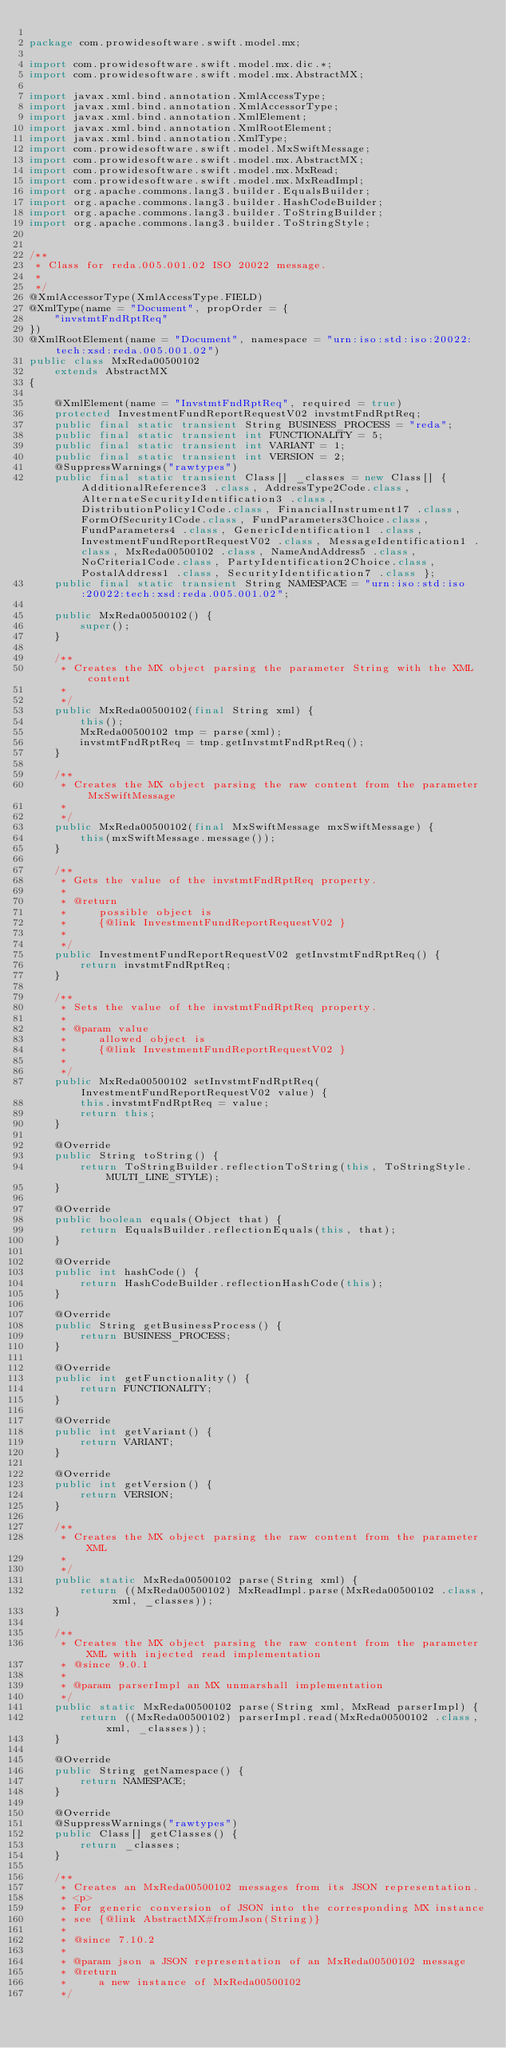<code> <loc_0><loc_0><loc_500><loc_500><_Java_>
package com.prowidesoftware.swift.model.mx;

import com.prowidesoftware.swift.model.mx.dic.*;
import com.prowidesoftware.swift.model.mx.AbstractMX;

import javax.xml.bind.annotation.XmlAccessType;
import javax.xml.bind.annotation.XmlAccessorType;
import javax.xml.bind.annotation.XmlElement;
import javax.xml.bind.annotation.XmlRootElement;
import javax.xml.bind.annotation.XmlType;
import com.prowidesoftware.swift.model.MxSwiftMessage;
import com.prowidesoftware.swift.model.mx.AbstractMX;
import com.prowidesoftware.swift.model.mx.MxRead;
import com.prowidesoftware.swift.model.mx.MxReadImpl;
import org.apache.commons.lang3.builder.EqualsBuilder;
import org.apache.commons.lang3.builder.HashCodeBuilder;
import org.apache.commons.lang3.builder.ToStringBuilder;
import org.apache.commons.lang3.builder.ToStringStyle;


/**
 * Class for reda.005.001.02 ISO 20022 message.
 * 
 */
@XmlAccessorType(XmlAccessType.FIELD)
@XmlType(name = "Document", propOrder = {
    "invstmtFndRptReq"
})
@XmlRootElement(name = "Document", namespace = "urn:iso:std:iso:20022:tech:xsd:reda.005.001.02")
public class MxReda00500102
    extends AbstractMX
{

    @XmlElement(name = "InvstmtFndRptReq", required = true)
    protected InvestmentFundReportRequestV02 invstmtFndRptReq;
    public final static transient String BUSINESS_PROCESS = "reda";
    public final static transient int FUNCTIONALITY = 5;
    public final static transient int VARIANT = 1;
    public final static transient int VERSION = 2;
    @SuppressWarnings("rawtypes")
    public final static transient Class[] _classes = new Class[] {AdditionalReference3 .class, AddressType2Code.class, AlternateSecurityIdentification3 .class, DistributionPolicy1Code.class, FinancialInstrument17 .class, FormOfSecurity1Code.class, FundParameters3Choice.class, FundParameters4 .class, GenericIdentification1 .class, InvestmentFundReportRequestV02 .class, MessageIdentification1 .class, MxReda00500102 .class, NameAndAddress5 .class, NoCriteria1Code.class, PartyIdentification2Choice.class, PostalAddress1 .class, SecurityIdentification7 .class };
    public final static transient String NAMESPACE = "urn:iso:std:iso:20022:tech:xsd:reda.005.001.02";

    public MxReda00500102() {
        super();
    }

    /**
     * Creates the MX object parsing the parameter String with the XML content
     * 
     */
    public MxReda00500102(final String xml) {
        this();
        MxReda00500102 tmp = parse(xml);
        invstmtFndRptReq = tmp.getInvstmtFndRptReq();
    }

    /**
     * Creates the MX object parsing the raw content from the parameter MxSwiftMessage
     * 
     */
    public MxReda00500102(final MxSwiftMessage mxSwiftMessage) {
        this(mxSwiftMessage.message());
    }

    /**
     * Gets the value of the invstmtFndRptReq property.
     * 
     * @return
     *     possible object is
     *     {@link InvestmentFundReportRequestV02 }
     *     
     */
    public InvestmentFundReportRequestV02 getInvstmtFndRptReq() {
        return invstmtFndRptReq;
    }

    /**
     * Sets the value of the invstmtFndRptReq property.
     * 
     * @param value
     *     allowed object is
     *     {@link InvestmentFundReportRequestV02 }
     *     
     */
    public MxReda00500102 setInvstmtFndRptReq(InvestmentFundReportRequestV02 value) {
        this.invstmtFndRptReq = value;
        return this;
    }

    @Override
    public String toString() {
        return ToStringBuilder.reflectionToString(this, ToStringStyle.MULTI_LINE_STYLE);
    }

    @Override
    public boolean equals(Object that) {
        return EqualsBuilder.reflectionEquals(this, that);
    }

    @Override
    public int hashCode() {
        return HashCodeBuilder.reflectionHashCode(this);
    }

    @Override
    public String getBusinessProcess() {
        return BUSINESS_PROCESS;
    }

    @Override
    public int getFunctionality() {
        return FUNCTIONALITY;
    }

    @Override
    public int getVariant() {
        return VARIANT;
    }

    @Override
    public int getVersion() {
        return VERSION;
    }

    /**
     * Creates the MX object parsing the raw content from the parameter XML
     * 
     */
    public static MxReda00500102 parse(String xml) {
        return ((MxReda00500102) MxReadImpl.parse(MxReda00500102 .class, xml, _classes));
    }

    /**
     * Creates the MX object parsing the raw content from the parameter XML with injected read implementation
     * @since 9.0.1
     * 
     * @param parserImpl an MX unmarshall implementation
     */
    public static MxReda00500102 parse(String xml, MxRead parserImpl) {
        return ((MxReda00500102) parserImpl.read(MxReda00500102 .class, xml, _classes));
    }

    @Override
    public String getNamespace() {
        return NAMESPACE;
    }

    @Override
    @SuppressWarnings("rawtypes")
    public Class[] getClasses() {
        return _classes;
    }

    /**
     * Creates an MxReda00500102 messages from its JSON representation.
     * <p>
     * For generic conversion of JSON into the corresponding MX instance 
     * see {@link AbstractMX#fromJson(String)}
     * 
     * @since 7.10.2
     * 
     * @param json a JSON representation of an MxReda00500102 message
     * @return
     *     a new instance of MxReda00500102
     */</code> 